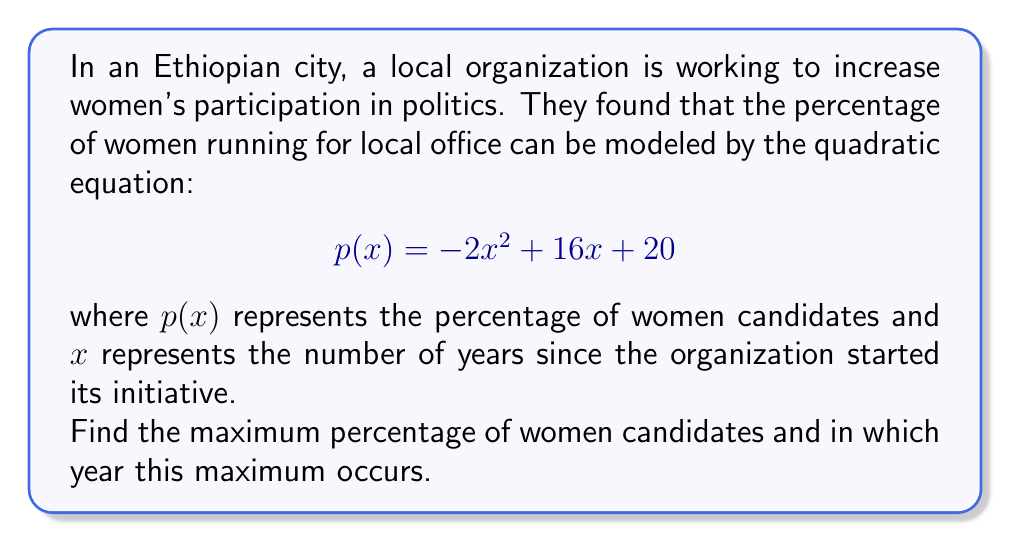Teach me how to tackle this problem. To solve this problem, we need to follow these steps:

1) The given quadratic equation is in the form $f(x) = ax^2 + bx + c$, where:
   $a = -2$, $b = 16$, and $c = 20$

2) For a quadratic function, the maximum (or minimum) occurs at the vertex of the parabola. Since $a$ is negative, this parabola opens downward and has a maximum.

3) To find the x-coordinate of the vertex, we use the formula: $x = -\frac{b}{2a}$

   $x = -\frac{16}{2(-2)} = -\frac{16}{-4} = 4$

4) This means the maximum occurs 4 years after the initiative started.

5) To find the maximum percentage, we substitute $x = 4$ into the original equation:

   $$\begin{align}
   p(4) &= -2(4)^2 + 16(4) + 20 \\
        &= -2(16) + 64 + 20 \\
        &= -32 + 64 + 20 \\
        &= 52
   \end{align}$$

Therefore, the maximum percentage of women candidates is 52%.
Answer: The maximum percentage of women candidates is 52%, occurring 4 years after the initiative started. 